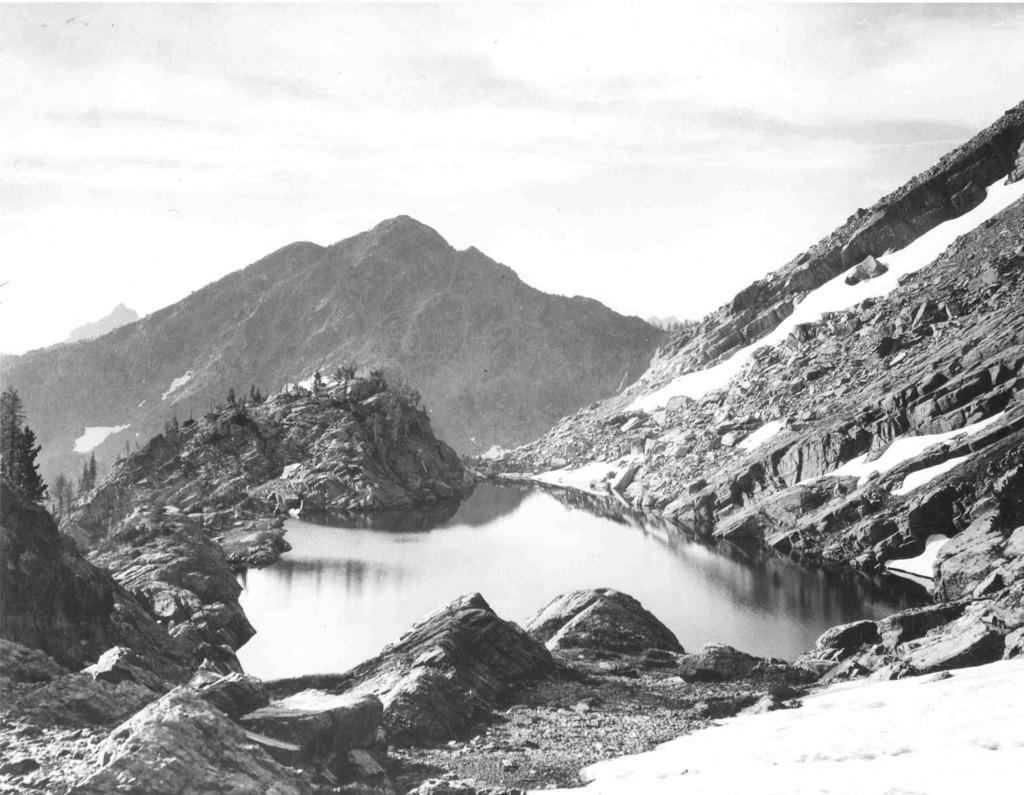What type of geographical feature can be seen in the image? There are hills in the image. What is the smaller water feature in the image? There is a small canal in the image. What type of vegetation is present on the hills? There are plants on the hills in the image. What type of learning activity is taking place on the hills in the image? There is no learning activity present in the image; it only features hills, a canal, and plants. What type of sticks are being used by the cook in the image? There is no cook or sticks present in the image. 